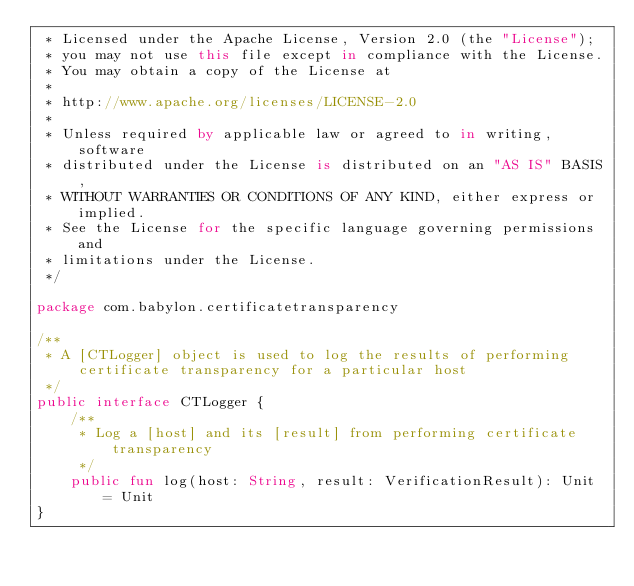<code> <loc_0><loc_0><loc_500><loc_500><_Kotlin_> * Licensed under the Apache License, Version 2.0 (the "License");
 * you may not use this file except in compliance with the License.
 * You may obtain a copy of the License at
 *
 * http://www.apache.org/licenses/LICENSE-2.0
 *
 * Unless required by applicable law or agreed to in writing, software
 * distributed under the License is distributed on an "AS IS" BASIS,
 * WITHOUT WARRANTIES OR CONDITIONS OF ANY KIND, either express or implied.
 * See the License for the specific language governing permissions and
 * limitations under the License.
 */

package com.babylon.certificatetransparency

/**
 * A [CTLogger] object is used to log the results of performing certificate transparency for a particular host
 */
public interface CTLogger {
    /**
     * Log a [host] and its [result] from performing certificate transparency
     */
    public fun log(host: String, result: VerificationResult): Unit = Unit
}
</code> 